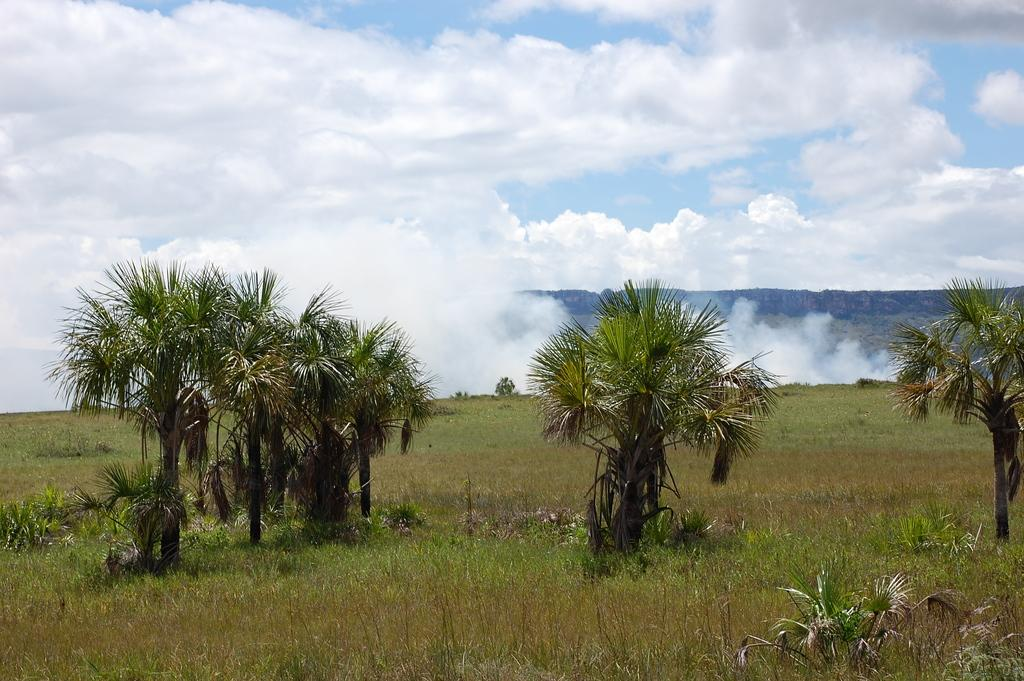What type of vegetation is present in the image? There are many trees in the image. What is the ground covered with in the image? There is grass in the image. What can be seen coming from the trees or buildings in the image? There is smoke visible in the image. What type of geographical feature is present in the image? There are mountains in the image. What is the condition of the sky in the image? The sky is cloudy in the image. How much profit can be made from the playground in the image? There is no playground present in the image, so it is not possible to determine any potential profit. 